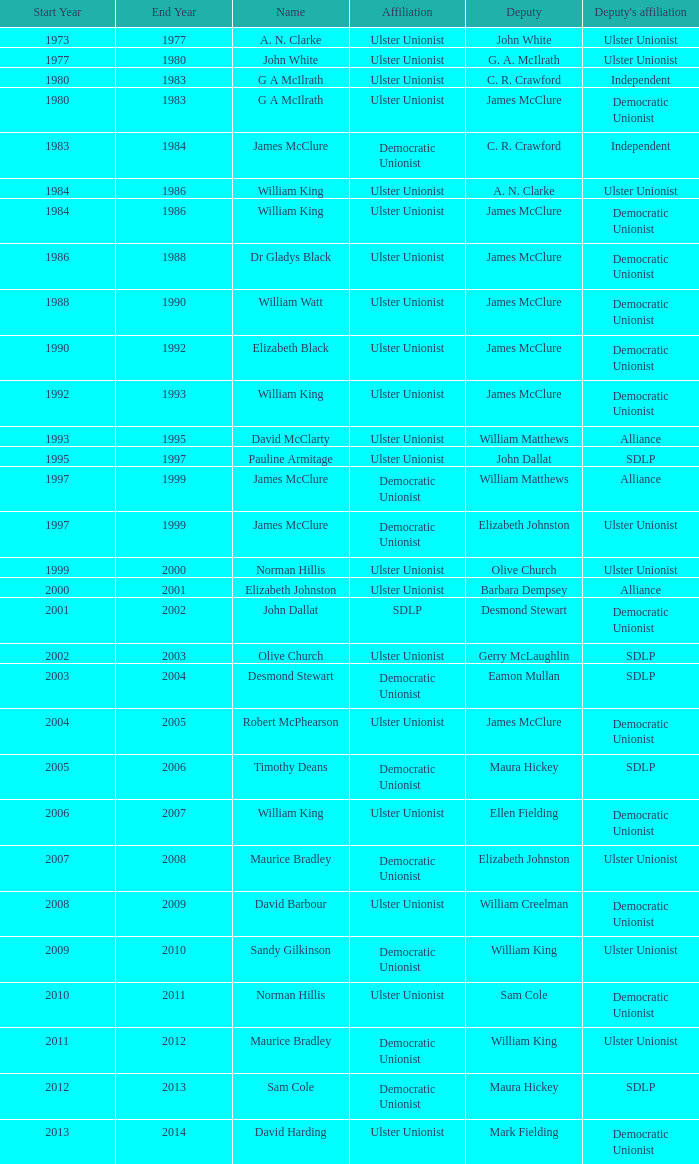What is the name of the deputy in 1992–93? James McClure. 